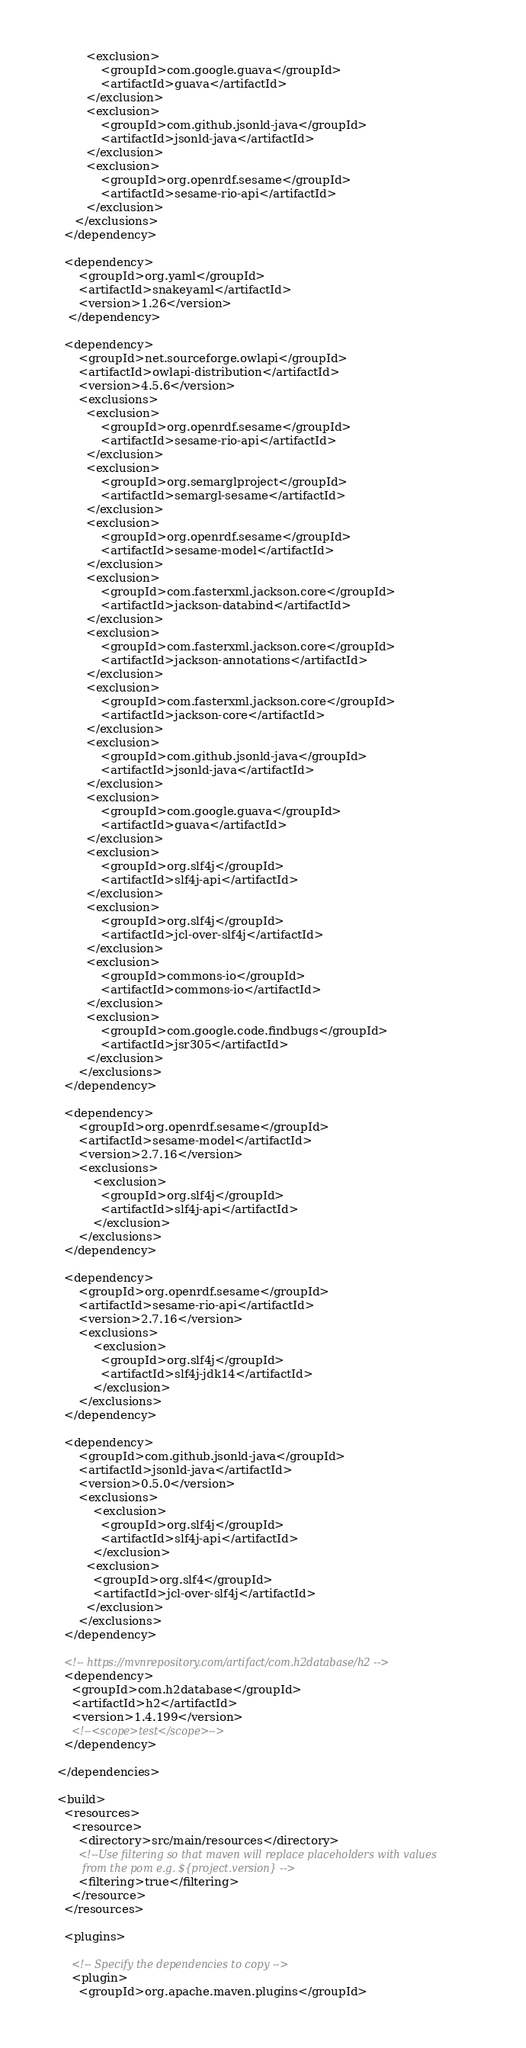Convert code to text. <code><loc_0><loc_0><loc_500><loc_500><_XML_>          <exclusion>
              <groupId>com.google.guava</groupId>
              <artifactId>guava</artifactId>
          </exclusion>
          <exclusion>
              <groupId>com.github.jsonld-java</groupId>
              <artifactId>jsonld-java</artifactId>
          </exclusion>
          <exclusion>
              <groupId>org.openrdf.sesame</groupId>
              <artifactId>sesame-rio-api</artifactId>
          </exclusion>
       </exclusions>
    </dependency>

    <dependency>
        <groupId>org.yaml</groupId>
        <artifactId>snakeyaml</artifactId>
        <version>1.26</version>
     </dependency>

    <dependency>
        <groupId>net.sourceforge.owlapi</groupId>
        <artifactId>owlapi-distribution</artifactId>
        <version>4.5.6</version>
        <exclusions>
          <exclusion>
              <groupId>org.openrdf.sesame</groupId>
              <artifactId>sesame-rio-api</artifactId>
          </exclusion>
          <exclusion>
              <groupId>org.semarglproject</groupId>
              <artifactId>semargl-sesame</artifactId>
          </exclusion>
          <exclusion>
              <groupId>org.openrdf.sesame</groupId>
              <artifactId>sesame-model</artifactId>
          </exclusion>
          <exclusion>
              <groupId>com.fasterxml.jackson.core</groupId>
              <artifactId>jackson-databind</artifactId>
          </exclusion>
          <exclusion>
              <groupId>com.fasterxml.jackson.core</groupId>
              <artifactId>jackson-annotations</artifactId>
          </exclusion>
          <exclusion>
              <groupId>com.fasterxml.jackson.core</groupId>
              <artifactId>jackson-core</artifactId>
          </exclusion>
          <exclusion>
              <groupId>com.github.jsonld-java</groupId>
              <artifactId>jsonld-java</artifactId>
          </exclusion>
          <exclusion>
              <groupId>com.google.guava</groupId>
              <artifactId>guava</artifactId>
          </exclusion>
          <exclusion>
              <groupId>org.slf4j</groupId>
              <artifactId>slf4j-api</artifactId>
          </exclusion>
          <exclusion>
              <groupId>org.slf4j</groupId>
              <artifactId>jcl-over-slf4j</artifactId>
          </exclusion>
          <exclusion>
              <groupId>commons-io</groupId>
              <artifactId>commons-io</artifactId>
          </exclusion>
          <exclusion>
              <groupId>com.google.code.findbugs</groupId>
              <artifactId>jsr305</artifactId>
          </exclusion>
        </exclusions>
    </dependency>

    <dependency>
        <groupId>org.openrdf.sesame</groupId>
        <artifactId>sesame-model</artifactId>
        <version>2.7.16</version>
        <exclusions>
            <exclusion>
              <groupId>org.slf4j</groupId>
              <artifactId>slf4j-api</artifactId>
            </exclusion>
        </exclusions>
    </dependency>

    <dependency>
        <groupId>org.openrdf.sesame</groupId>
        <artifactId>sesame-rio-api</artifactId>
        <version>2.7.16</version>
        <exclusions>
            <exclusion>
              <groupId>org.slf4j</groupId>
              <artifactId>slf4j-jdk14</artifactId>
            </exclusion>
        </exclusions>
    </dependency>

    <dependency>
        <groupId>com.github.jsonld-java</groupId>
        <artifactId>jsonld-java</artifactId>
        <version>0.5.0</version>
        <exclusions>
            <exclusion>
              <groupId>org.slf4j</groupId>
              <artifactId>slf4j-api</artifactId>
            </exclusion>
          <exclusion>
            <groupId>org.slf4</groupId>
            <artifactId>jcl-over-slf4j</artifactId>
          </exclusion>
        </exclusions>
    </dependency>

    <!-- https://mvnrepository.com/artifact/com.h2database/h2 -->
    <dependency>
      <groupId>com.h2database</groupId>
      <artifactId>h2</artifactId>
      <version>1.4.199</version>
      <!--<scope>test</scope>-->
    </dependency>

  </dependencies>

  <build>
    <resources>
      <resource>
        <directory>src/main/resources</directory>
        <!--Use filtering so that maven will replace placeholders with values
          from the pom e.g. ${project.version} -->
        <filtering>true</filtering>
      </resource>
    </resources>

    <plugins>

      <!-- Specify the dependencies to copy -->
      <plugin>
        <groupId>org.apache.maven.plugins</groupId></code> 